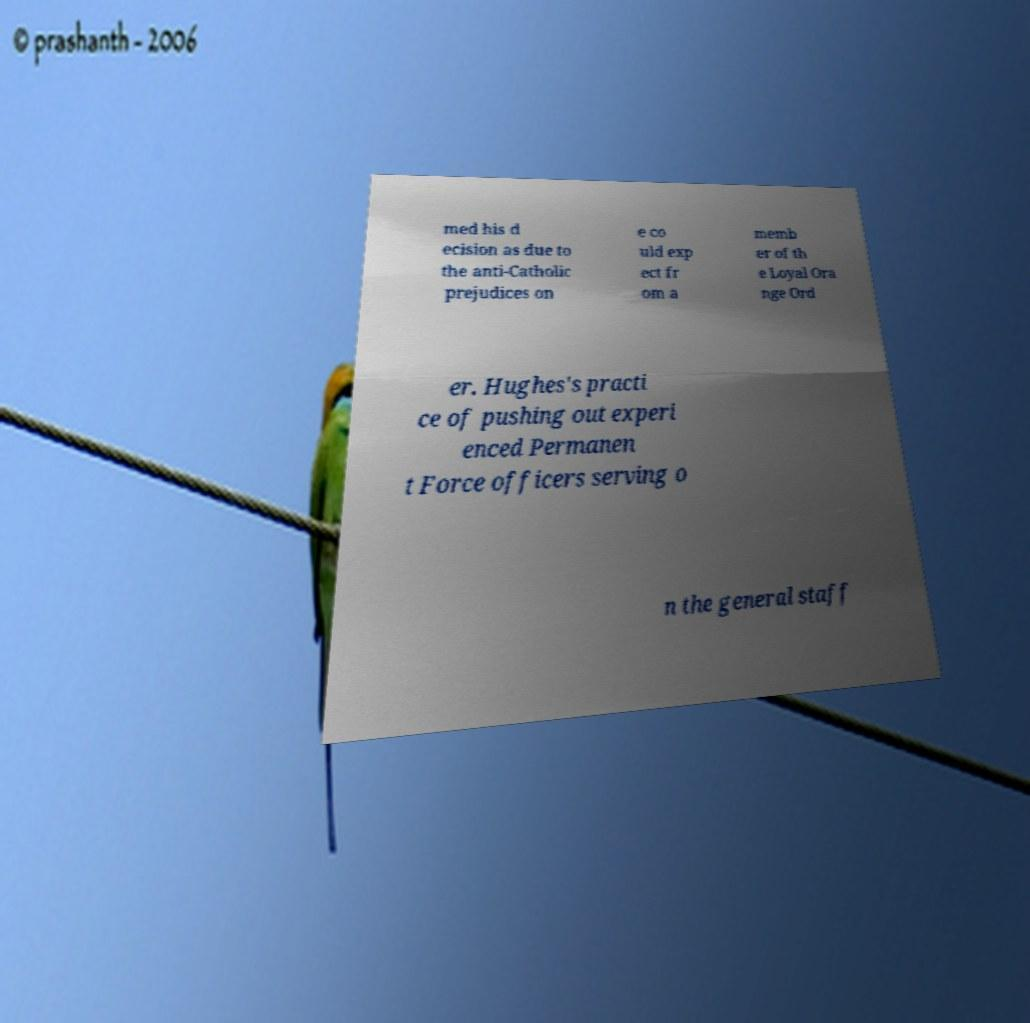Can you accurately transcribe the text from the provided image for me? med his d ecision as due to the anti-Catholic prejudices on e co uld exp ect fr om a memb er of th e Loyal Ora nge Ord er. Hughes's practi ce of pushing out experi enced Permanen t Force officers serving o n the general staff 